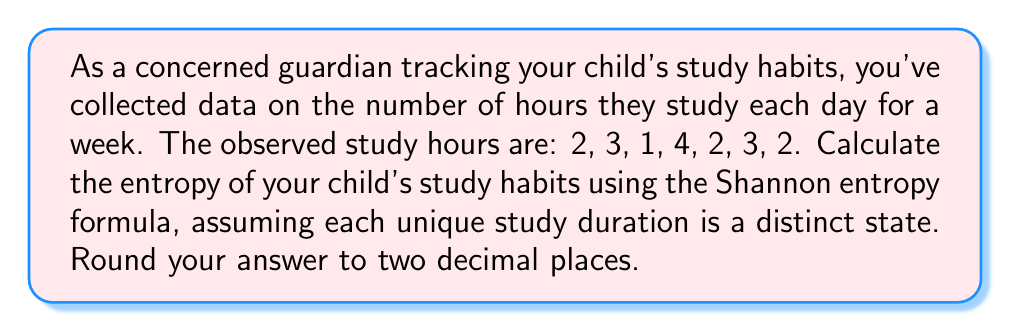What is the answer to this math problem? To calculate the entropy of the student's study habits, we'll use the Shannon entropy formula:

$$ S = -\sum_{i} p_i \log_2(p_i) $$

Where $S$ is the entropy, and $p_i$ is the probability of each state.

Step 1: Identify unique states and their frequencies
- 1 hour: occurs 1 time
- 2 hours: occurs 3 times
- 3 hours: occurs 2 times
- 4 hours: occurs 1 time

Step 2: Calculate probabilities
Total observations: 7
$p(1) = 1/7$
$p(2) = 3/7$
$p(3) = 2/7$
$p(4) = 1/7$

Step 3: Apply the Shannon entropy formula
$$ S = -\left(\frac{1}{7} \log_2\left(\frac{1}{7}\right) + \frac{3}{7} \log_2\left(\frac{3}{7}\right) + \frac{2}{7} \log_2\left(\frac{2}{7}\right) + \frac{1}{7} \log_2\left(\frac{1}{7}\right)\right) $$

Step 4: Calculate each term
$\frac{1}{7} \log_2\left(\frac{1}{7}\right) \approx -0.3956$
$\frac{3}{7} \log_2\left(\frac{3}{7}\right) \approx -0.3789$
$\frac{2}{7} \log_2\left(\frac{2}{7}\right) \approx -0.3429$
$\frac{1}{7} \log_2\left(\frac{1}{7}\right) \approx -0.3956$

Step 5: Sum the terms and take the negative
$S = -(-0.3956 - 0.3789 - 0.3429 - 0.3956) \approx 1.5130$

Step 6: Round to two decimal places
$S \approx 1.51$
Answer: 1.51 bits 